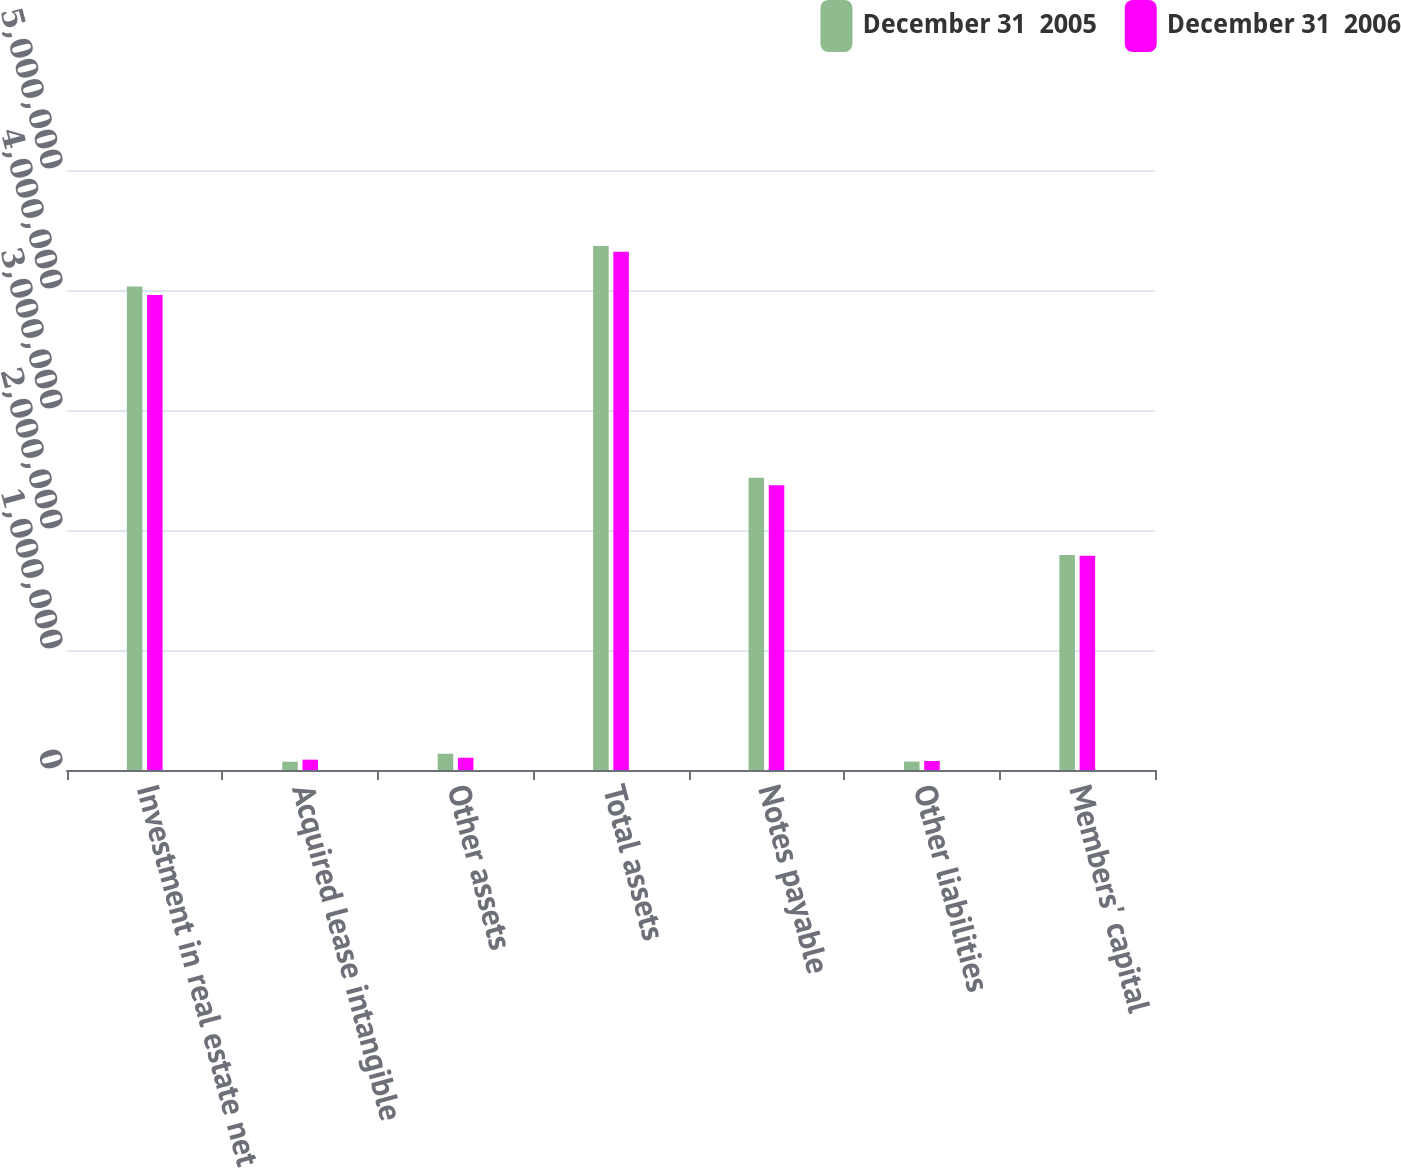Convert chart to OTSL. <chart><loc_0><loc_0><loc_500><loc_500><stacked_bar_chart><ecel><fcel>Investment in real estate net<fcel>Acquired lease intangible<fcel>Other assets<fcel>Total assets<fcel>Notes payable<fcel>Other liabilities<fcel>Members' capital<nl><fcel>December 31  2005<fcel>4.02939e+06<fcel>69336<fcel>135451<fcel>4.36568e+06<fcel>2.43523e+06<fcel>70295<fcel>1.79082e+06<nl><fcel>December 31  2006<fcel>3.95751e+06<fcel>86108<fcel>102041<fcel>4.31858e+06<fcel>2.3726e+06<fcel>75282<fcel>1.78459e+06<nl></chart> 